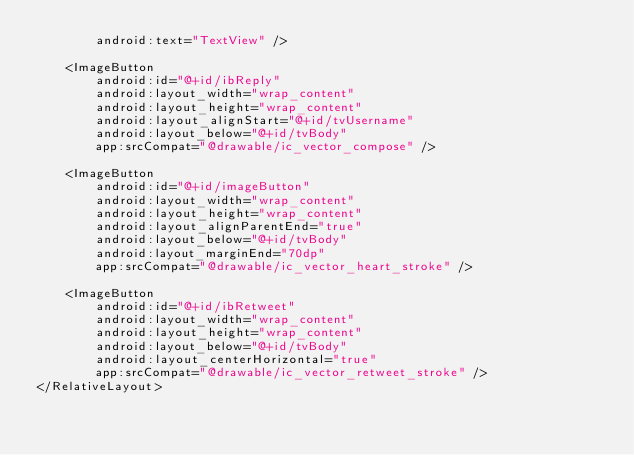<code> <loc_0><loc_0><loc_500><loc_500><_XML_>        android:text="TextView" />

    <ImageButton
        android:id="@+id/ibReply"
        android:layout_width="wrap_content"
        android:layout_height="wrap_content"
        android:layout_alignStart="@+id/tvUsername"
        android:layout_below="@+id/tvBody"
        app:srcCompat="@drawable/ic_vector_compose" />

    <ImageButton
        android:id="@+id/imageButton"
        android:layout_width="wrap_content"
        android:layout_height="wrap_content"
        android:layout_alignParentEnd="true"
        android:layout_below="@+id/tvBody"
        android:layout_marginEnd="70dp"
        app:srcCompat="@drawable/ic_vector_heart_stroke" />

    <ImageButton
        android:id="@+id/ibRetweet"
        android:layout_width="wrap_content"
        android:layout_height="wrap_content"
        android:layout_below="@+id/tvBody"
        android:layout_centerHorizontal="true"
        app:srcCompat="@drawable/ic_vector_retweet_stroke" />
</RelativeLayout></code> 